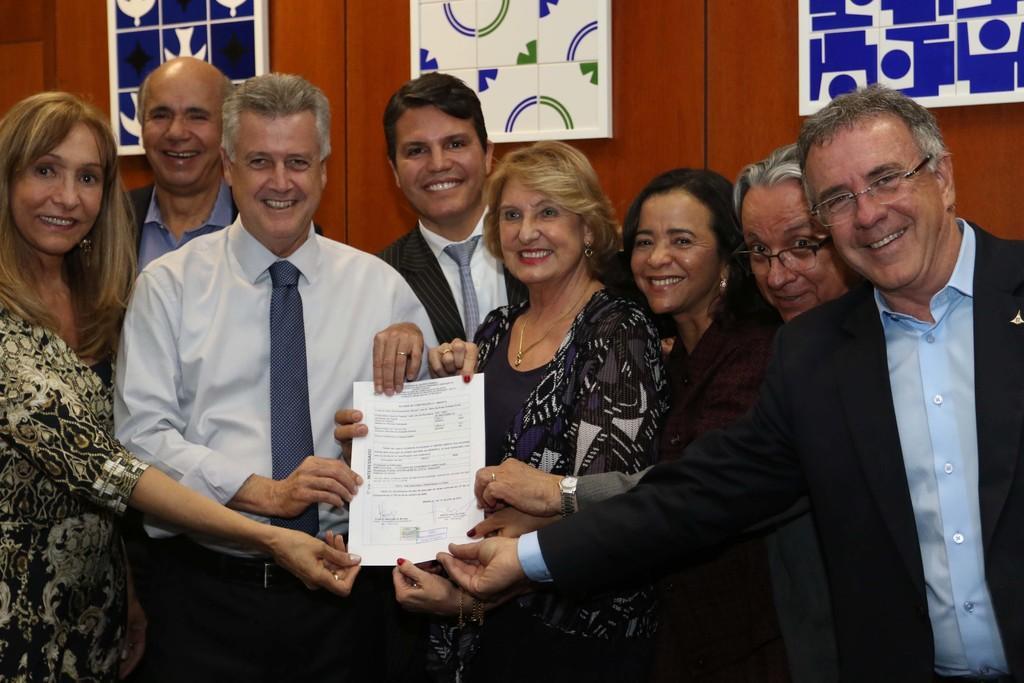Can you describe this image briefly? In the image few people are standing and smiling and holding a paper. Behind them there is a wall, on the wall there are some frames. 